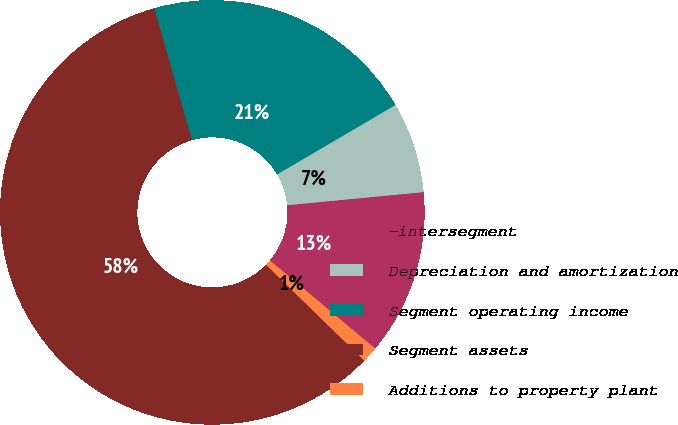<chart> <loc_0><loc_0><loc_500><loc_500><pie_chart><fcel>-intersegment<fcel>Depreciation and amortization<fcel>Segment operating income<fcel>Segment assets<fcel>Additions to property plant<nl><fcel>12.62%<fcel>6.92%<fcel>20.97%<fcel>58.28%<fcel>1.21%<nl></chart> 